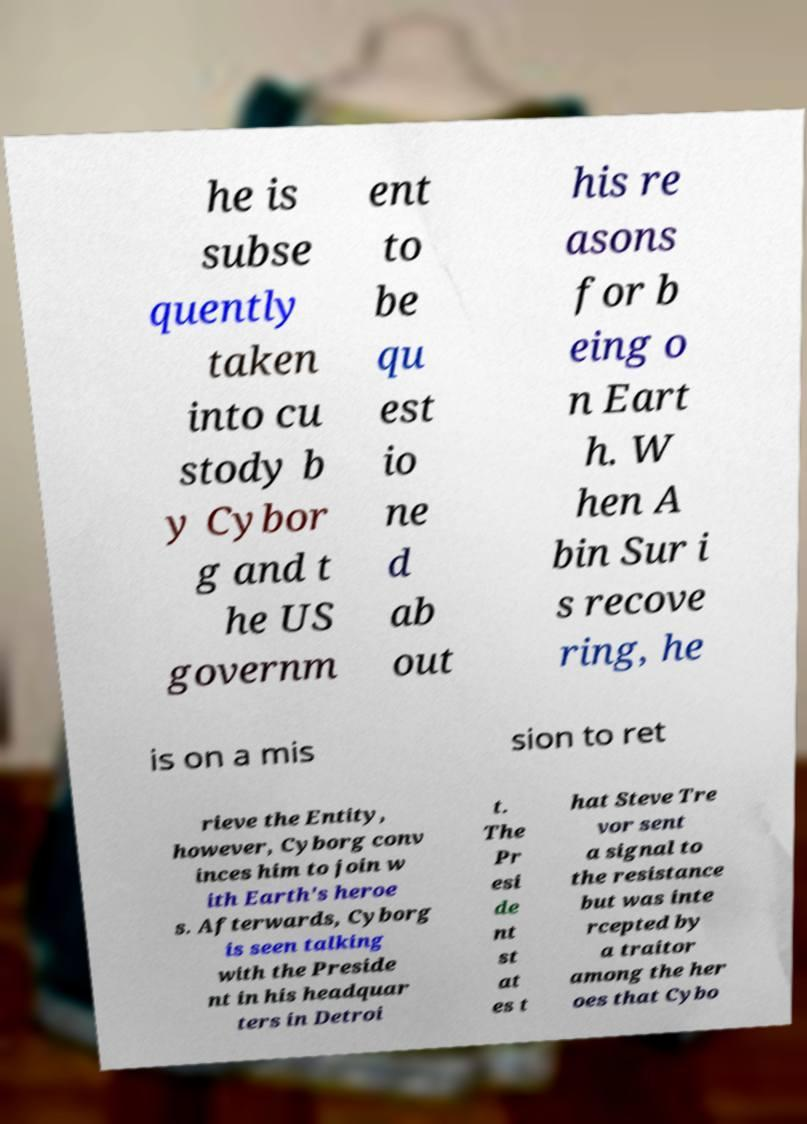Can you read and provide the text displayed in the image?This photo seems to have some interesting text. Can you extract and type it out for me? he is subse quently taken into cu stody b y Cybor g and t he US governm ent to be qu est io ne d ab out his re asons for b eing o n Eart h. W hen A bin Sur i s recove ring, he is on a mis sion to ret rieve the Entity, however, Cyborg conv inces him to join w ith Earth's heroe s. Afterwards, Cyborg is seen talking with the Preside nt in his headquar ters in Detroi t. The Pr esi de nt st at es t hat Steve Tre vor sent a signal to the resistance but was inte rcepted by a traitor among the her oes that Cybo 